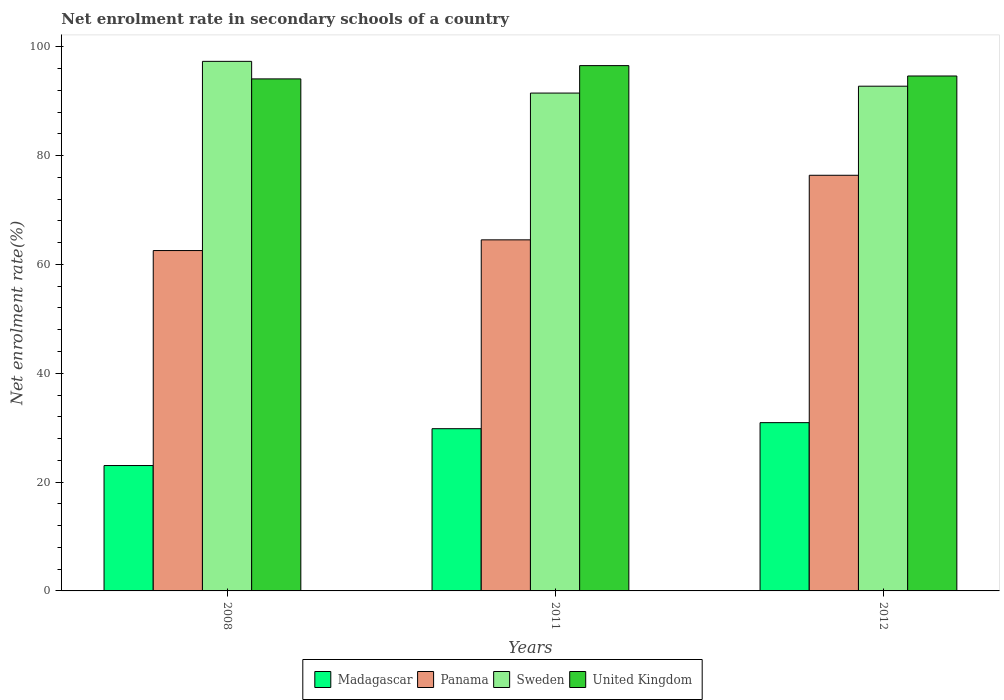Are the number of bars on each tick of the X-axis equal?
Your answer should be compact. Yes. How many bars are there on the 2nd tick from the right?
Provide a short and direct response. 4. What is the label of the 2nd group of bars from the left?
Provide a succinct answer. 2011. In how many cases, is the number of bars for a given year not equal to the number of legend labels?
Ensure brevity in your answer.  0. What is the net enrolment rate in secondary schools in Panama in 2008?
Provide a succinct answer. 62.55. Across all years, what is the maximum net enrolment rate in secondary schools in Madagascar?
Your response must be concise. 30.93. Across all years, what is the minimum net enrolment rate in secondary schools in United Kingdom?
Your response must be concise. 94.1. What is the total net enrolment rate in secondary schools in Sweden in the graph?
Provide a short and direct response. 281.58. What is the difference between the net enrolment rate in secondary schools in Panama in 2011 and that in 2012?
Your response must be concise. -11.87. What is the difference between the net enrolment rate in secondary schools in United Kingdom in 2011 and the net enrolment rate in secondary schools in Madagascar in 2012?
Give a very brief answer. 65.61. What is the average net enrolment rate in secondary schools in United Kingdom per year?
Your answer should be compact. 95.09. In the year 2012, what is the difference between the net enrolment rate in secondary schools in Sweden and net enrolment rate in secondary schools in Panama?
Keep it short and to the point. 16.37. In how many years, is the net enrolment rate in secondary schools in Sweden greater than 36 %?
Your answer should be very brief. 3. What is the ratio of the net enrolment rate in secondary schools in Panama in 2008 to that in 2011?
Your answer should be compact. 0.97. What is the difference between the highest and the second highest net enrolment rate in secondary schools in Sweden?
Give a very brief answer. 4.56. What is the difference between the highest and the lowest net enrolment rate in secondary schools in Panama?
Your answer should be compact. 13.83. Is the sum of the net enrolment rate in secondary schools in United Kingdom in 2011 and 2012 greater than the maximum net enrolment rate in secondary schools in Panama across all years?
Your answer should be very brief. Yes. Is it the case that in every year, the sum of the net enrolment rate in secondary schools in United Kingdom and net enrolment rate in secondary schools in Madagascar is greater than the sum of net enrolment rate in secondary schools in Sweden and net enrolment rate in secondary schools in Panama?
Keep it short and to the point. No. What does the 2nd bar from the left in 2011 represents?
Your answer should be compact. Panama. What does the 4th bar from the right in 2011 represents?
Your answer should be compact. Madagascar. How many bars are there?
Keep it short and to the point. 12. Are all the bars in the graph horizontal?
Your answer should be very brief. No. How many years are there in the graph?
Offer a terse response. 3. Does the graph contain any zero values?
Make the answer very short. No. Where does the legend appear in the graph?
Ensure brevity in your answer.  Bottom center. How many legend labels are there?
Ensure brevity in your answer.  4. How are the legend labels stacked?
Keep it short and to the point. Horizontal. What is the title of the graph?
Offer a terse response. Net enrolment rate in secondary schools of a country. What is the label or title of the X-axis?
Give a very brief answer. Years. What is the label or title of the Y-axis?
Your answer should be compact. Net enrolment rate(%). What is the Net enrolment rate(%) of Madagascar in 2008?
Provide a succinct answer. 23.04. What is the Net enrolment rate(%) of Panama in 2008?
Provide a short and direct response. 62.55. What is the Net enrolment rate(%) in Sweden in 2008?
Ensure brevity in your answer.  97.32. What is the Net enrolment rate(%) of United Kingdom in 2008?
Offer a terse response. 94.1. What is the Net enrolment rate(%) in Madagascar in 2011?
Your response must be concise. 29.81. What is the Net enrolment rate(%) of Panama in 2011?
Offer a terse response. 64.52. What is the Net enrolment rate(%) of Sweden in 2011?
Your answer should be compact. 91.49. What is the Net enrolment rate(%) of United Kingdom in 2011?
Your response must be concise. 96.54. What is the Net enrolment rate(%) of Madagascar in 2012?
Keep it short and to the point. 30.93. What is the Net enrolment rate(%) in Panama in 2012?
Keep it short and to the point. 76.39. What is the Net enrolment rate(%) of Sweden in 2012?
Your answer should be compact. 92.76. What is the Net enrolment rate(%) of United Kingdom in 2012?
Provide a short and direct response. 94.63. Across all years, what is the maximum Net enrolment rate(%) of Madagascar?
Provide a short and direct response. 30.93. Across all years, what is the maximum Net enrolment rate(%) in Panama?
Offer a very short reply. 76.39. Across all years, what is the maximum Net enrolment rate(%) in Sweden?
Keep it short and to the point. 97.32. Across all years, what is the maximum Net enrolment rate(%) in United Kingdom?
Provide a succinct answer. 96.54. Across all years, what is the minimum Net enrolment rate(%) of Madagascar?
Provide a succinct answer. 23.04. Across all years, what is the minimum Net enrolment rate(%) of Panama?
Your answer should be very brief. 62.55. Across all years, what is the minimum Net enrolment rate(%) of Sweden?
Your response must be concise. 91.49. Across all years, what is the minimum Net enrolment rate(%) of United Kingdom?
Provide a succinct answer. 94.1. What is the total Net enrolment rate(%) of Madagascar in the graph?
Give a very brief answer. 83.78. What is the total Net enrolment rate(%) in Panama in the graph?
Your response must be concise. 203.46. What is the total Net enrolment rate(%) in Sweden in the graph?
Provide a succinct answer. 281.58. What is the total Net enrolment rate(%) of United Kingdom in the graph?
Your answer should be compact. 285.27. What is the difference between the Net enrolment rate(%) in Madagascar in 2008 and that in 2011?
Your response must be concise. -6.77. What is the difference between the Net enrolment rate(%) in Panama in 2008 and that in 2011?
Provide a short and direct response. -1.97. What is the difference between the Net enrolment rate(%) of Sweden in 2008 and that in 2011?
Your response must be concise. 5.83. What is the difference between the Net enrolment rate(%) of United Kingdom in 2008 and that in 2011?
Give a very brief answer. -2.44. What is the difference between the Net enrolment rate(%) in Madagascar in 2008 and that in 2012?
Keep it short and to the point. -7.88. What is the difference between the Net enrolment rate(%) in Panama in 2008 and that in 2012?
Keep it short and to the point. -13.83. What is the difference between the Net enrolment rate(%) in Sweden in 2008 and that in 2012?
Offer a terse response. 4.56. What is the difference between the Net enrolment rate(%) of United Kingdom in 2008 and that in 2012?
Your response must be concise. -0.53. What is the difference between the Net enrolment rate(%) in Madagascar in 2011 and that in 2012?
Your response must be concise. -1.11. What is the difference between the Net enrolment rate(%) of Panama in 2011 and that in 2012?
Your answer should be very brief. -11.87. What is the difference between the Net enrolment rate(%) in Sweden in 2011 and that in 2012?
Give a very brief answer. -1.26. What is the difference between the Net enrolment rate(%) of United Kingdom in 2011 and that in 2012?
Ensure brevity in your answer.  1.91. What is the difference between the Net enrolment rate(%) of Madagascar in 2008 and the Net enrolment rate(%) of Panama in 2011?
Your response must be concise. -41.48. What is the difference between the Net enrolment rate(%) of Madagascar in 2008 and the Net enrolment rate(%) of Sweden in 2011?
Provide a succinct answer. -68.45. What is the difference between the Net enrolment rate(%) of Madagascar in 2008 and the Net enrolment rate(%) of United Kingdom in 2011?
Provide a succinct answer. -73.5. What is the difference between the Net enrolment rate(%) in Panama in 2008 and the Net enrolment rate(%) in Sweden in 2011?
Offer a terse response. -28.94. What is the difference between the Net enrolment rate(%) in Panama in 2008 and the Net enrolment rate(%) in United Kingdom in 2011?
Offer a very short reply. -33.99. What is the difference between the Net enrolment rate(%) of Sweden in 2008 and the Net enrolment rate(%) of United Kingdom in 2011?
Offer a very short reply. 0.78. What is the difference between the Net enrolment rate(%) of Madagascar in 2008 and the Net enrolment rate(%) of Panama in 2012?
Keep it short and to the point. -53.34. What is the difference between the Net enrolment rate(%) of Madagascar in 2008 and the Net enrolment rate(%) of Sweden in 2012?
Offer a very short reply. -69.72. What is the difference between the Net enrolment rate(%) in Madagascar in 2008 and the Net enrolment rate(%) in United Kingdom in 2012?
Offer a terse response. -71.59. What is the difference between the Net enrolment rate(%) of Panama in 2008 and the Net enrolment rate(%) of Sweden in 2012?
Your answer should be compact. -30.21. What is the difference between the Net enrolment rate(%) in Panama in 2008 and the Net enrolment rate(%) in United Kingdom in 2012?
Your answer should be compact. -32.08. What is the difference between the Net enrolment rate(%) in Sweden in 2008 and the Net enrolment rate(%) in United Kingdom in 2012?
Your answer should be compact. 2.69. What is the difference between the Net enrolment rate(%) of Madagascar in 2011 and the Net enrolment rate(%) of Panama in 2012?
Provide a succinct answer. -46.57. What is the difference between the Net enrolment rate(%) of Madagascar in 2011 and the Net enrolment rate(%) of Sweden in 2012?
Give a very brief answer. -62.95. What is the difference between the Net enrolment rate(%) of Madagascar in 2011 and the Net enrolment rate(%) of United Kingdom in 2012?
Offer a very short reply. -64.82. What is the difference between the Net enrolment rate(%) in Panama in 2011 and the Net enrolment rate(%) in Sweden in 2012?
Your answer should be very brief. -28.24. What is the difference between the Net enrolment rate(%) of Panama in 2011 and the Net enrolment rate(%) of United Kingdom in 2012?
Make the answer very short. -30.11. What is the difference between the Net enrolment rate(%) in Sweden in 2011 and the Net enrolment rate(%) in United Kingdom in 2012?
Your response must be concise. -3.14. What is the average Net enrolment rate(%) in Madagascar per year?
Your response must be concise. 27.93. What is the average Net enrolment rate(%) in Panama per year?
Give a very brief answer. 67.82. What is the average Net enrolment rate(%) in Sweden per year?
Keep it short and to the point. 93.86. What is the average Net enrolment rate(%) in United Kingdom per year?
Offer a very short reply. 95.09. In the year 2008, what is the difference between the Net enrolment rate(%) of Madagascar and Net enrolment rate(%) of Panama?
Provide a short and direct response. -39.51. In the year 2008, what is the difference between the Net enrolment rate(%) of Madagascar and Net enrolment rate(%) of Sweden?
Give a very brief answer. -74.28. In the year 2008, what is the difference between the Net enrolment rate(%) of Madagascar and Net enrolment rate(%) of United Kingdom?
Offer a very short reply. -71.06. In the year 2008, what is the difference between the Net enrolment rate(%) of Panama and Net enrolment rate(%) of Sweden?
Your answer should be very brief. -34.77. In the year 2008, what is the difference between the Net enrolment rate(%) of Panama and Net enrolment rate(%) of United Kingdom?
Ensure brevity in your answer.  -31.55. In the year 2008, what is the difference between the Net enrolment rate(%) of Sweden and Net enrolment rate(%) of United Kingdom?
Your answer should be compact. 3.23. In the year 2011, what is the difference between the Net enrolment rate(%) of Madagascar and Net enrolment rate(%) of Panama?
Give a very brief answer. -34.71. In the year 2011, what is the difference between the Net enrolment rate(%) in Madagascar and Net enrolment rate(%) in Sweden?
Make the answer very short. -61.68. In the year 2011, what is the difference between the Net enrolment rate(%) of Madagascar and Net enrolment rate(%) of United Kingdom?
Keep it short and to the point. -66.73. In the year 2011, what is the difference between the Net enrolment rate(%) of Panama and Net enrolment rate(%) of Sweden?
Offer a terse response. -26.97. In the year 2011, what is the difference between the Net enrolment rate(%) in Panama and Net enrolment rate(%) in United Kingdom?
Give a very brief answer. -32.02. In the year 2011, what is the difference between the Net enrolment rate(%) in Sweden and Net enrolment rate(%) in United Kingdom?
Your answer should be very brief. -5.04. In the year 2012, what is the difference between the Net enrolment rate(%) of Madagascar and Net enrolment rate(%) of Panama?
Make the answer very short. -45.46. In the year 2012, what is the difference between the Net enrolment rate(%) of Madagascar and Net enrolment rate(%) of Sweden?
Ensure brevity in your answer.  -61.83. In the year 2012, what is the difference between the Net enrolment rate(%) in Madagascar and Net enrolment rate(%) in United Kingdom?
Give a very brief answer. -63.71. In the year 2012, what is the difference between the Net enrolment rate(%) in Panama and Net enrolment rate(%) in Sweden?
Your answer should be compact. -16.37. In the year 2012, what is the difference between the Net enrolment rate(%) in Panama and Net enrolment rate(%) in United Kingdom?
Keep it short and to the point. -18.25. In the year 2012, what is the difference between the Net enrolment rate(%) of Sweden and Net enrolment rate(%) of United Kingdom?
Your response must be concise. -1.87. What is the ratio of the Net enrolment rate(%) of Madagascar in 2008 to that in 2011?
Offer a terse response. 0.77. What is the ratio of the Net enrolment rate(%) of Panama in 2008 to that in 2011?
Your answer should be compact. 0.97. What is the ratio of the Net enrolment rate(%) in Sweden in 2008 to that in 2011?
Your answer should be very brief. 1.06. What is the ratio of the Net enrolment rate(%) of United Kingdom in 2008 to that in 2011?
Offer a very short reply. 0.97. What is the ratio of the Net enrolment rate(%) of Madagascar in 2008 to that in 2012?
Provide a succinct answer. 0.75. What is the ratio of the Net enrolment rate(%) in Panama in 2008 to that in 2012?
Make the answer very short. 0.82. What is the ratio of the Net enrolment rate(%) in Sweden in 2008 to that in 2012?
Offer a terse response. 1.05. What is the ratio of the Net enrolment rate(%) of United Kingdom in 2008 to that in 2012?
Make the answer very short. 0.99. What is the ratio of the Net enrolment rate(%) of Madagascar in 2011 to that in 2012?
Your answer should be very brief. 0.96. What is the ratio of the Net enrolment rate(%) of Panama in 2011 to that in 2012?
Give a very brief answer. 0.84. What is the ratio of the Net enrolment rate(%) of Sweden in 2011 to that in 2012?
Offer a terse response. 0.99. What is the ratio of the Net enrolment rate(%) in United Kingdom in 2011 to that in 2012?
Offer a terse response. 1.02. What is the difference between the highest and the second highest Net enrolment rate(%) in Madagascar?
Offer a terse response. 1.11. What is the difference between the highest and the second highest Net enrolment rate(%) in Panama?
Provide a succinct answer. 11.87. What is the difference between the highest and the second highest Net enrolment rate(%) in Sweden?
Keep it short and to the point. 4.56. What is the difference between the highest and the second highest Net enrolment rate(%) in United Kingdom?
Make the answer very short. 1.91. What is the difference between the highest and the lowest Net enrolment rate(%) of Madagascar?
Give a very brief answer. 7.88. What is the difference between the highest and the lowest Net enrolment rate(%) in Panama?
Provide a short and direct response. 13.83. What is the difference between the highest and the lowest Net enrolment rate(%) in Sweden?
Your answer should be compact. 5.83. What is the difference between the highest and the lowest Net enrolment rate(%) of United Kingdom?
Make the answer very short. 2.44. 